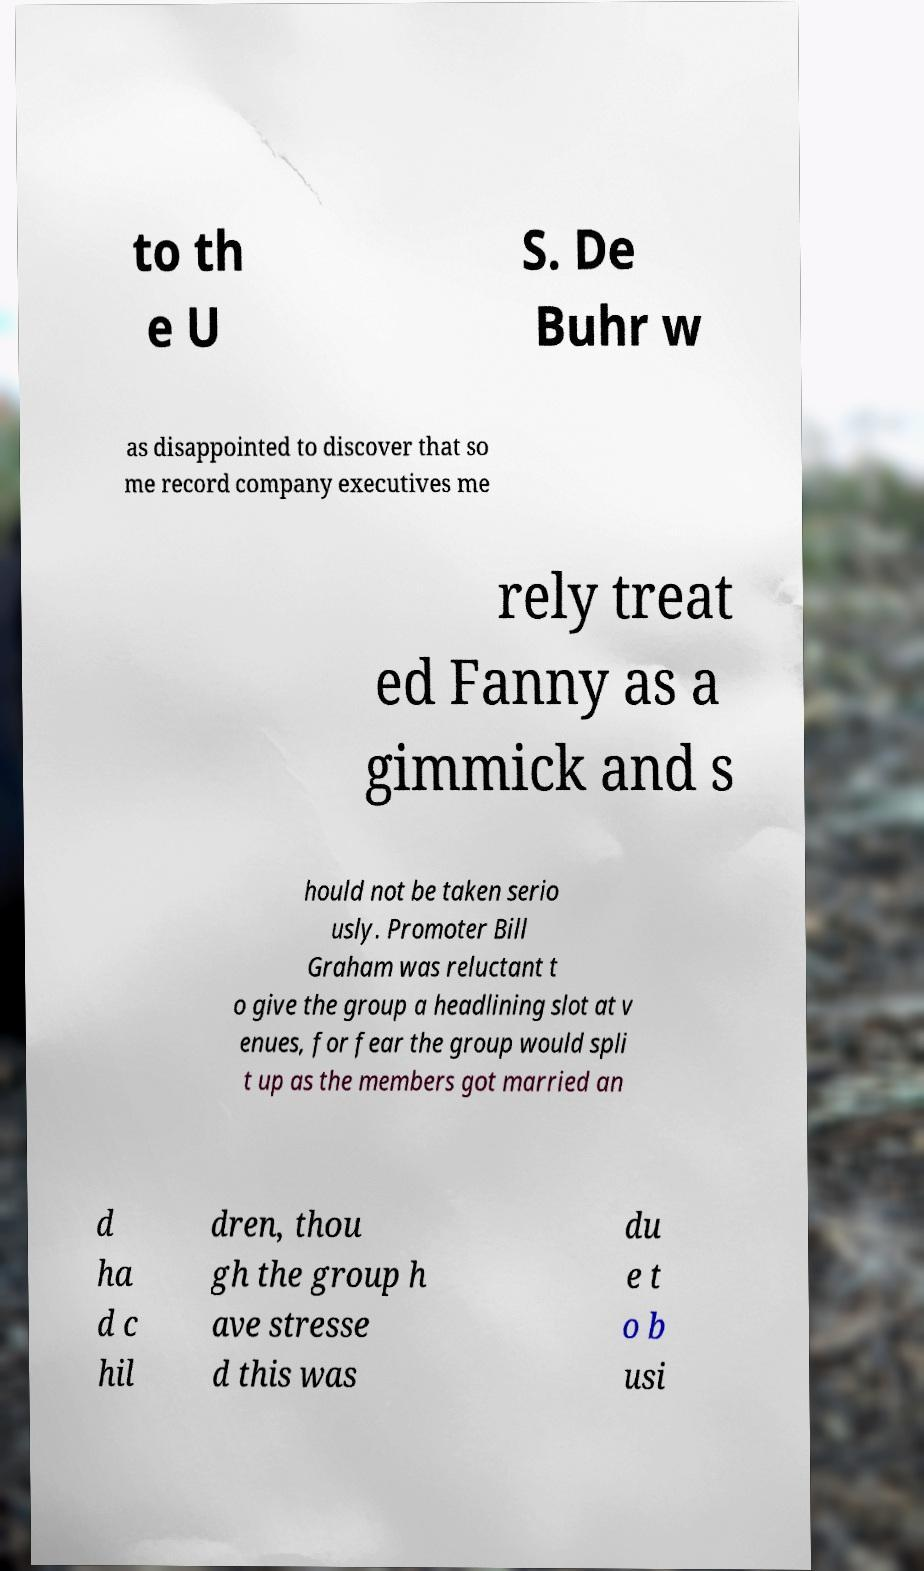Could you assist in decoding the text presented in this image and type it out clearly? to th e U S. De Buhr w as disappointed to discover that so me record company executives me rely treat ed Fanny as a gimmick and s hould not be taken serio usly. Promoter Bill Graham was reluctant t o give the group a headlining slot at v enues, for fear the group would spli t up as the members got married an d ha d c hil dren, thou gh the group h ave stresse d this was du e t o b usi 